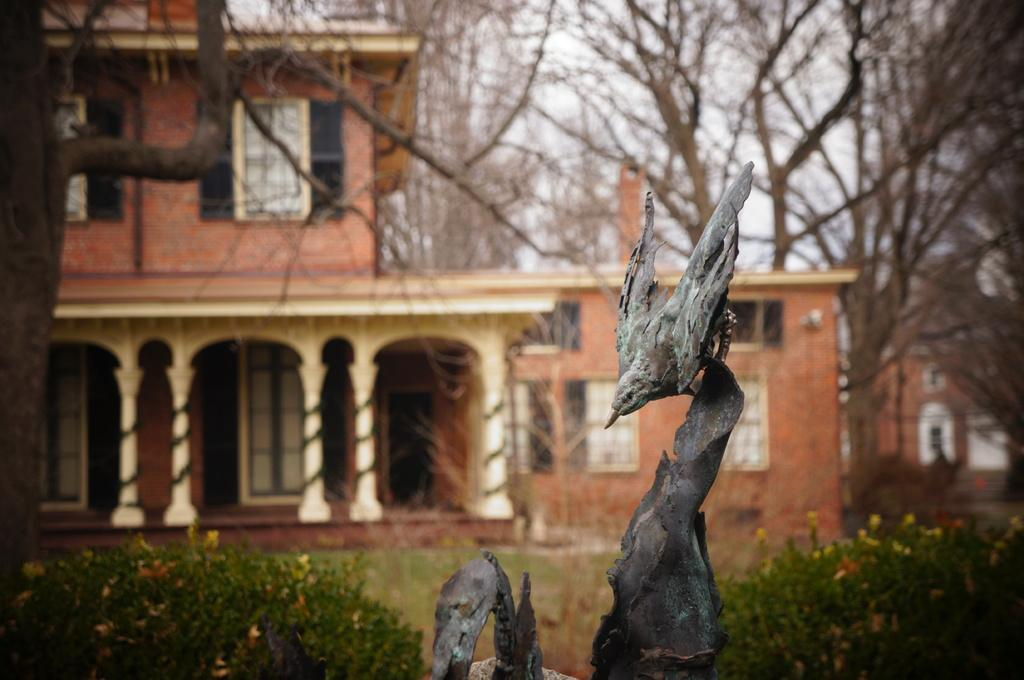What animal can be seen in the picture? There is a bird in the picture. What is the bird doing in the picture? The bird is sitting. What type of natural environment is visible in the backdrop of the picture? There is grass, plants, trees, and a building in the backdrop of the picture. What is the condition of the sky in the backdrop of the picture? The sky is clear in the backdrop of the picture. How many jellyfish can be seen swimming in the picture? There are no jellyfish present in the picture; it features a bird sitting in a natural environment. What causes the bird to sneeze in the picture? There is no indication in the picture that the bird is sneezing, and birds do not have the same respiratory system as humans. 